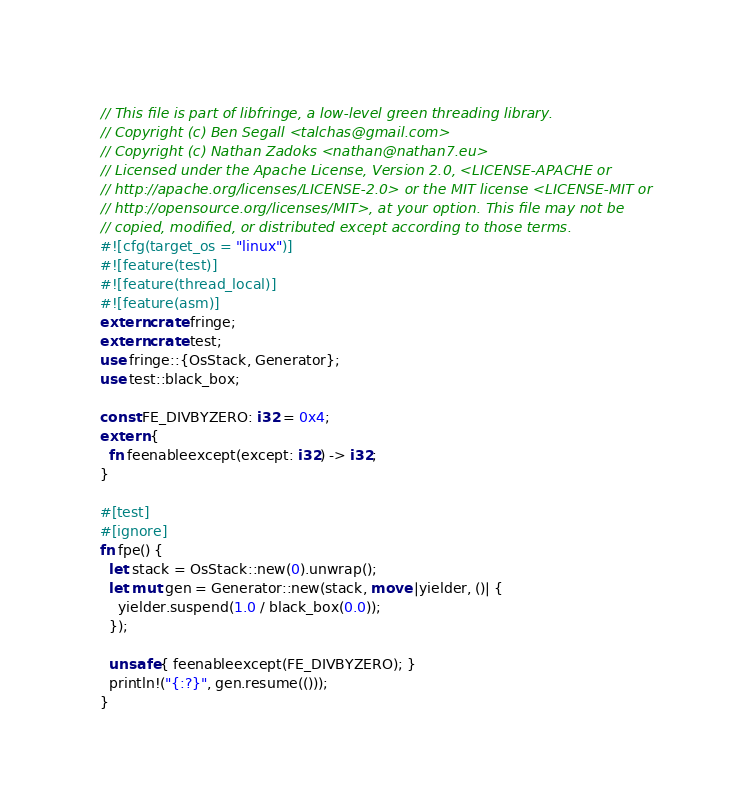<code> <loc_0><loc_0><loc_500><loc_500><_Rust_>// This file is part of libfringe, a low-level green threading library.
// Copyright (c) Ben Segall <talchas@gmail.com>
// Copyright (c) Nathan Zadoks <nathan@nathan7.eu>
// Licensed under the Apache License, Version 2.0, <LICENSE-APACHE or
// http://apache.org/licenses/LICENSE-2.0> or the MIT license <LICENSE-MIT or
// http://opensource.org/licenses/MIT>, at your option. This file may not be
// copied, modified, or distributed except according to those terms.
#![cfg(target_os = "linux")]
#![feature(test)]
#![feature(thread_local)]
#![feature(asm)]
extern crate fringe;
extern crate test;
use fringe::{OsStack, Generator};
use test::black_box;

const FE_DIVBYZERO: i32 = 0x4;
extern {
  fn feenableexcept(except: i32) -> i32;
}

#[test]
#[ignore]
fn fpe() {
  let stack = OsStack::new(0).unwrap();
  let mut gen = Generator::new(stack, move |yielder, ()| {
    yielder.suspend(1.0 / black_box(0.0));
  });

  unsafe { feenableexcept(FE_DIVBYZERO); }
  println!("{:?}", gen.resume(()));
}
</code> 